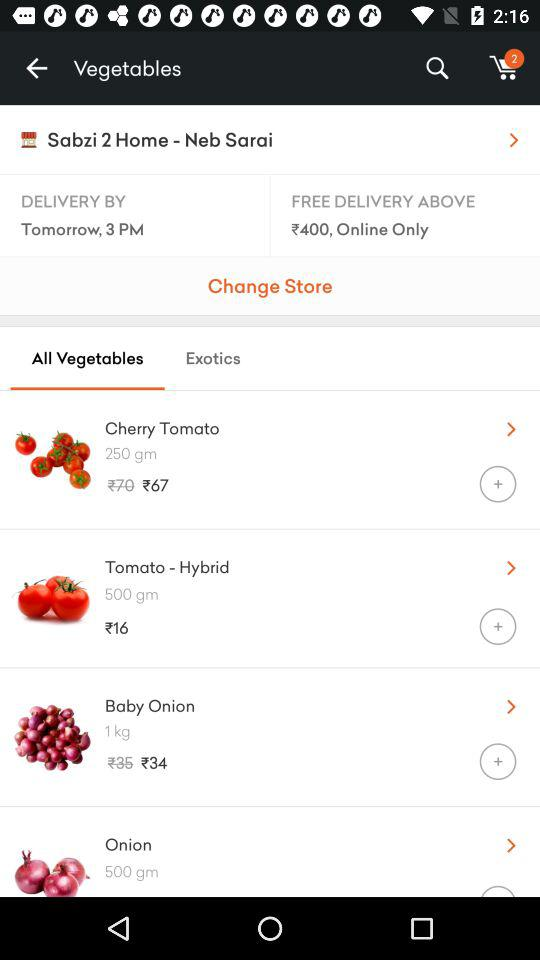What is the name of the shop where you get these vegetables? The name of the shop is "Sabzi 2 Home". 